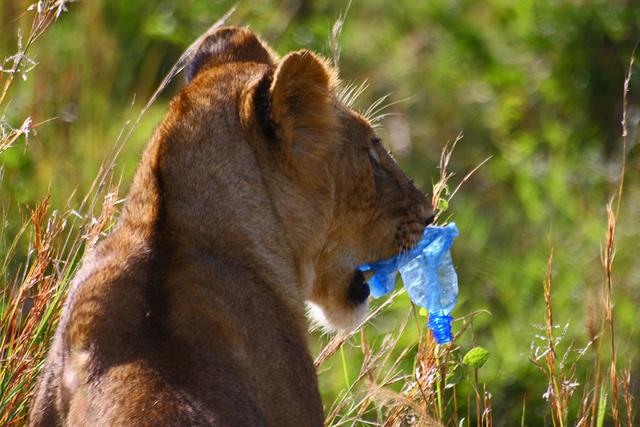Is this out in nature?
Give a very brief answer. Yes. What is the animal eating?
Keep it brief. Plastic bottle. Is the bottle empty?
Keep it brief. Yes. 